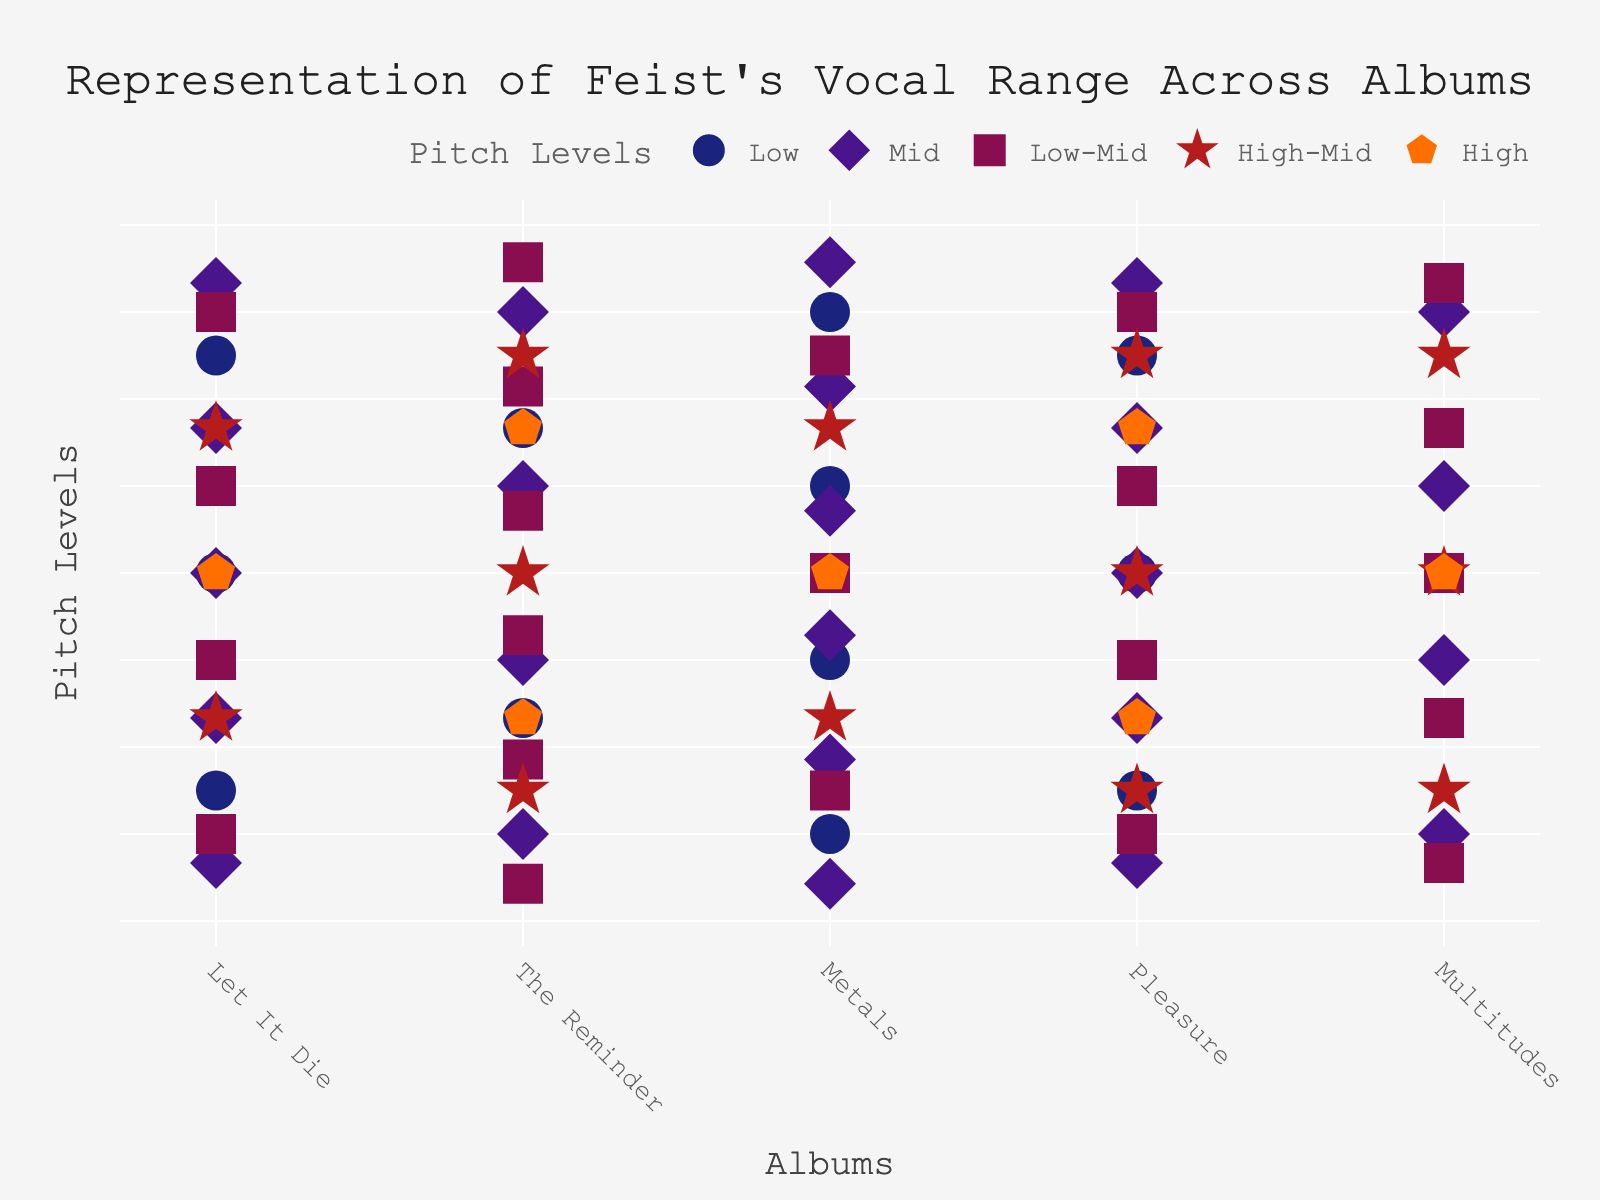What is the title of the plot? The title can be found at the top of the figure and provides an overall description of the visual data. In this case, it states the main focus of the plot.
Answer: Representation of Feist's Vocal Range Across Albums How many albums are represented in the plot? To determine this, count the number of unique album names on the x-axis.
Answer: 5 Which album has the highest number of 'Low' pitch symbols? Compare the number of 'Low' pitch icons across each album. 'Low' symbols are circles in dark blue.
Answer: Metals Which album contains the most 'Low-Mid' pitch symbols? Compare the quantity of 'Low-Mid' pitch symbols (squares in purple) among all the albums.
Answer: The Reminder Do all albums have at least one 'Mid' pitch symbol? Check each album's representation for the presence of 'Mid' pitch symbols (diamonds in violet).
Answer: Yes How many 'High-Mid' symbols are there in total across all albums? Add the number of 'High-Mid' symbols (stars in red) across each album.
Answer: 13 Which album has the greatest variety in vocal range? Identify the album with the most different types (colors/shapes) of pitch symbols present.
Answer: The Reminder Compare the number of 'High' pitch symbols in 'The Reminder' and 'Multitudes.' Which one has more? Check the count of 'High' symbols (pentagons in orange) in both albums and compare.
Answer: The Reminder What is the sum of 'Low' and 'Low-Mid' pitch symbols in 'Let It Die'? Add the number of 'Low' and 'Low-Mid' symbols in 'Let It Die.' 'Low' symbols are circles and 'Low-Mid' symbols are squares.
Answer: 7 Does 'Pleasure' have more 'High' or 'Low' pitch symbols? Compare the counts of 'High' (pentagons in orange) and 'Low' (circles in dark blue) pitch symbols in 'Pleasure.'
Answer: Low 